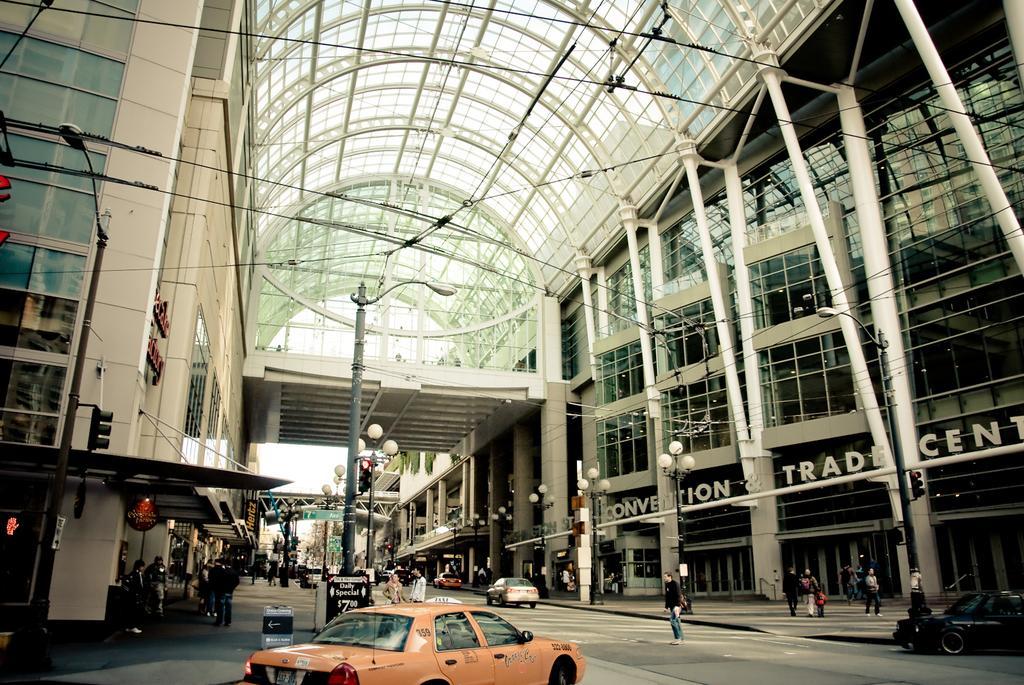Could you give a brief overview of what you see in this image? In this picture I can see a roof on the buildings, under some people are walking and also I can see few vehicles on the road. 